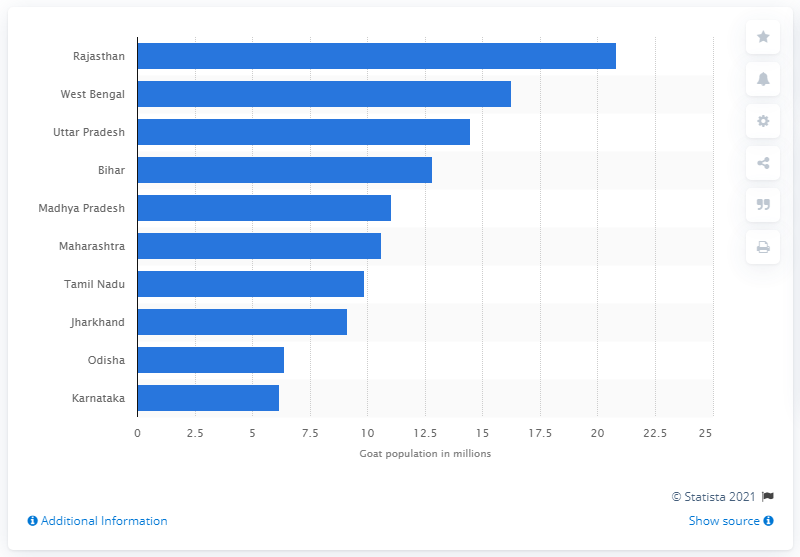Draw attention to some important aspects in this diagram. Uttar Pradesh had the highest goat population in India in 2019. 